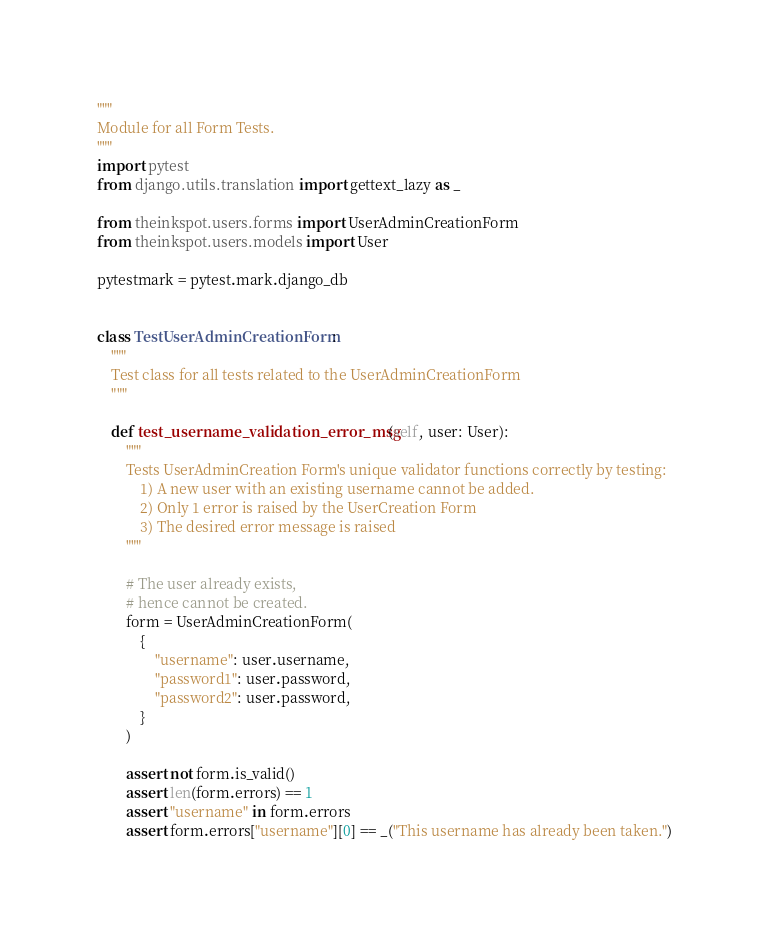Convert code to text. <code><loc_0><loc_0><loc_500><loc_500><_Python_>"""
Module for all Form Tests.
"""
import pytest
from django.utils.translation import gettext_lazy as _

from theinkspot.users.forms import UserAdminCreationForm
from theinkspot.users.models import User

pytestmark = pytest.mark.django_db


class TestUserAdminCreationForm:
    """
    Test class for all tests related to the UserAdminCreationForm
    """

    def test_username_validation_error_msg(self, user: User):
        """
        Tests UserAdminCreation Form's unique validator functions correctly by testing:
            1) A new user with an existing username cannot be added.
            2) Only 1 error is raised by the UserCreation Form
            3) The desired error message is raised
        """

        # The user already exists,
        # hence cannot be created.
        form = UserAdminCreationForm(
            {
                "username": user.username,
                "password1": user.password,
                "password2": user.password,
            }
        )

        assert not form.is_valid()
        assert len(form.errors) == 1
        assert "username" in form.errors
        assert form.errors["username"][0] == _("This username has already been taken.")
</code> 